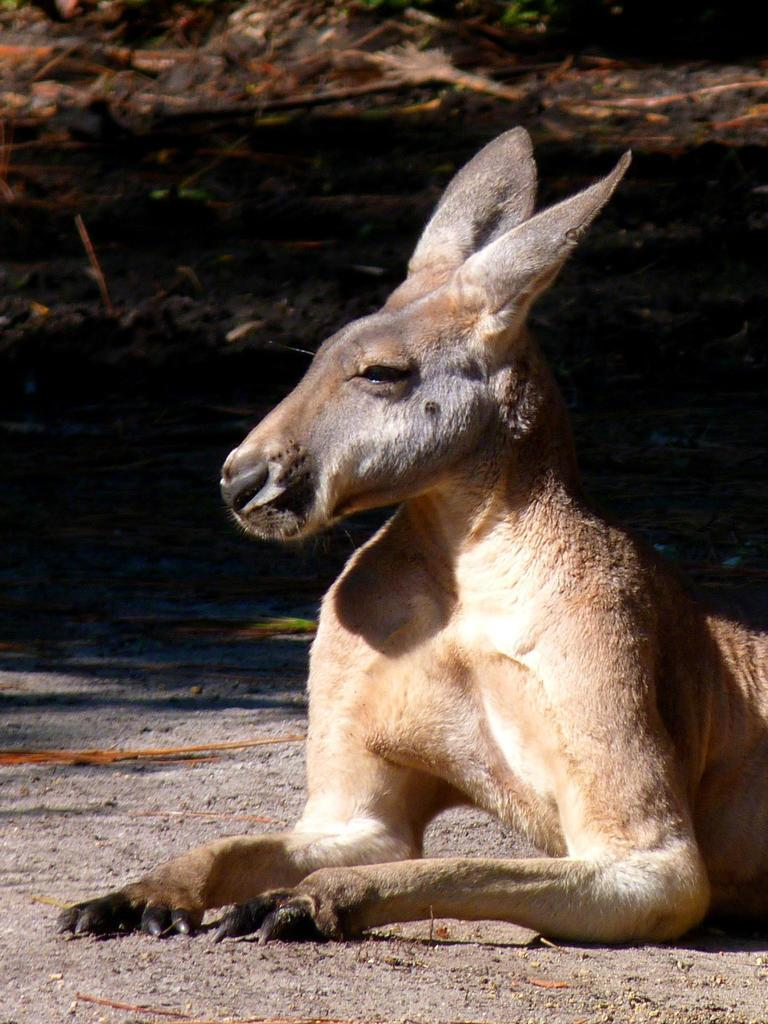What type of living creature is present in the image? There is an animal in the image. Can you describe the animal's position or location in the image? The animal is sitting on the land. What type of plantation can be seen in the background of the image? There is no plantation present in the image; it only features an animal sitting on the land. How many dimes are visible on the animal's back in the image? There are no dimes visible on the animal's back in the image. 